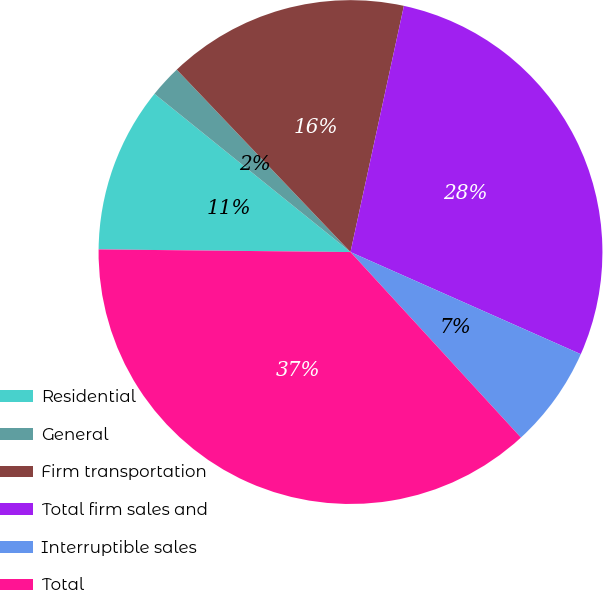Convert chart. <chart><loc_0><loc_0><loc_500><loc_500><pie_chart><fcel>Residential<fcel>General<fcel>Firm transportation<fcel>Total firm sales and<fcel>Interruptible sales<fcel>Total<nl><fcel>10.64%<fcel>2.08%<fcel>15.51%<fcel>28.24%<fcel>6.53%<fcel>36.99%<nl></chart> 